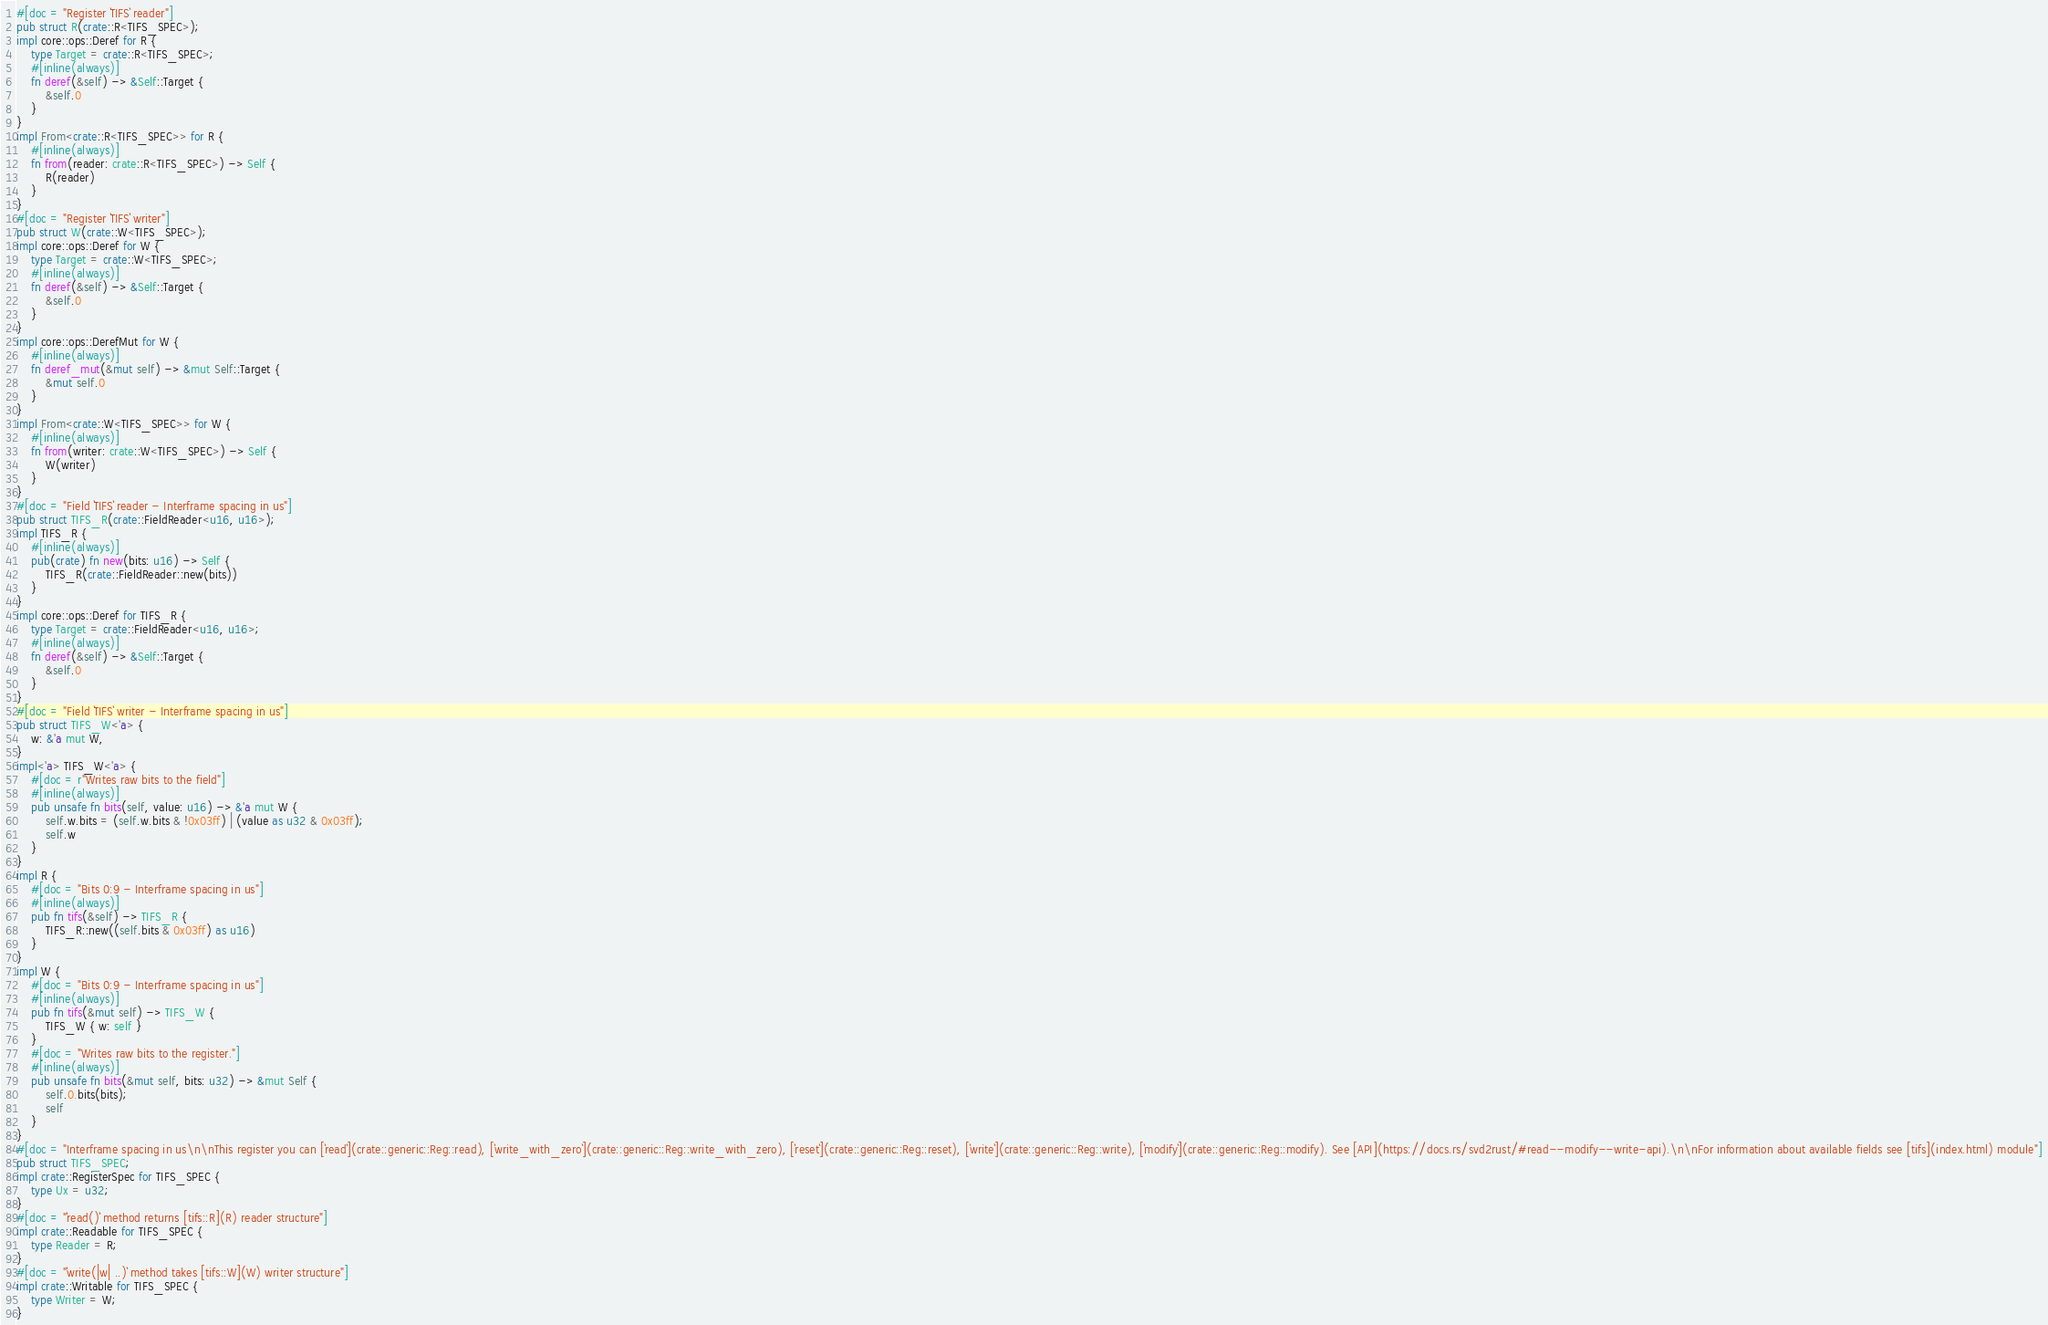Convert code to text. <code><loc_0><loc_0><loc_500><loc_500><_Rust_>#[doc = "Register `TIFS` reader"]
pub struct R(crate::R<TIFS_SPEC>);
impl core::ops::Deref for R {
    type Target = crate::R<TIFS_SPEC>;
    #[inline(always)]
    fn deref(&self) -> &Self::Target {
        &self.0
    }
}
impl From<crate::R<TIFS_SPEC>> for R {
    #[inline(always)]
    fn from(reader: crate::R<TIFS_SPEC>) -> Self {
        R(reader)
    }
}
#[doc = "Register `TIFS` writer"]
pub struct W(crate::W<TIFS_SPEC>);
impl core::ops::Deref for W {
    type Target = crate::W<TIFS_SPEC>;
    #[inline(always)]
    fn deref(&self) -> &Self::Target {
        &self.0
    }
}
impl core::ops::DerefMut for W {
    #[inline(always)]
    fn deref_mut(&mut self) -> &mut Self::Target {
        &mut self.0
    }
}
impl From<crate::W<TIFS_SPEC>> for W {
    #[inline(always)]
    fn from(writer: crate::W<TIFS_SPEC>) -> Self {
        W(writer)
    }
}
#[doc = "Field `TIFS` reader - Interframe spacing in us"]
pub struct TIFS_R(crate::FieldReader<u16, u16>);
impl TIFS_R {
    #[inline(always)]
    pub(crate) fn new(bits: u16) -> Self {
        TIFS_R(crate::FieldReader::new(bits))
    }
}
impl core::ops::Deref for TIFS_R {
    type Target = crate::FieldReader<u16, u16>;
    #[inline(always)]
    fn deref(&self) -> &Self::Target {
        &self.0
    }
}
#[doc = "Field `TIFS` writer - Interframe spacing in us"]
pub struct TIFS_W<'a> {
    w: &'a mut W,
}
impl<'a> TIFS_W<'a> {
    #[doc = r"Writes raw bits to the field"]
    #[inline(always)]
    pub unsafe fn bits(self, value: u16) -> &'a mut W {
        self.w.bits = (self.w.bits & !0x03ff) | (value as u32 & 0x03ff);
        self.w
    }
}
impl R {
    #[doc = "Bits 0:9 - Interframe spacing in us"]
    #[inline(always)]
    pub fn tifs(&self) -> TIFS_R {
        TIFS_R::new((self.bits & 0x03ff) as u16)
    }
}
impl W {
    #[doc = "Bits 0:9 - Interframe spacing in us"]
    #[inline(always)]
    pub fn tifs(&mut self) -> TIFS_W {
        TIFS_W { w: self }
    }
    #[doc = "Writes raw bits to the register."]
    #[inline(always)]
    pub unsafe fn bits(&mut self, bits: u32) -> &mut Self {
        self.0.bits(bits);
        self
    }
}
#[doc = "Interframe spacing in us\n\nThis register you can [`read`](crate::generic::Reg::read), [`write_with_zero`](crate::generic::Reg::write_with_zero), [`reset`](crate::generic::Reg::reset), [`write`](crate::generic::Reg::write), [`modify`](crate::generic::Reg::modify). See [API](https://docs.rs/svd2rust/#read--modify--write-api).\n\nFor information about available fields see [tifs](index.html) module"]
pub struct TIFS_SPEC;
impl crate::RegisterSpec for TIFS_SPEC {
    type Ux = u32;
}
#[doc = "`read()` method returns [tifs::R](R) reader structure"]
impl crate::Readable for TIFS_SPEC {
    type Reader = R;
}
#[doc = "`write(|w| ..)` method takes [tifs::W](W) writer structure"]
impl crate::Writable for TIFS_SPEC {
    type Writer = W;
}</code> 